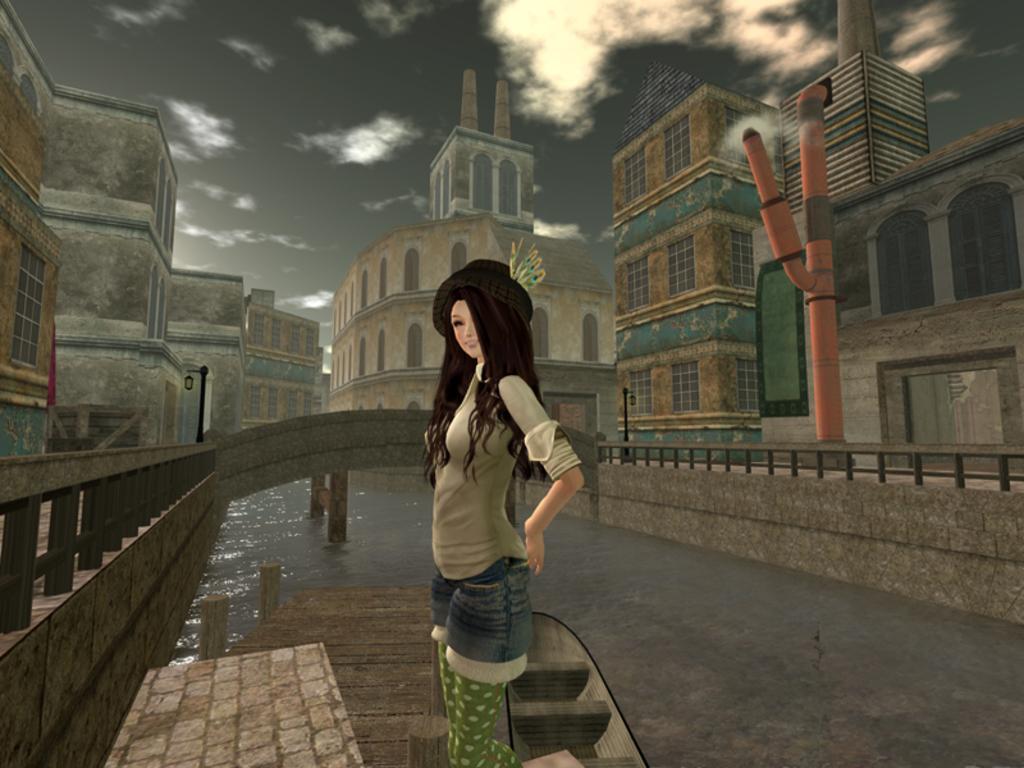Please provide a concise description of this image. This is an animation picture. In this image there is a woman standing. There is a boat on the water. At the back there is a bridge and there are buildings and there are poles and there is a railing. At the top there is sky and there are clouds. At the bottom there is water. 